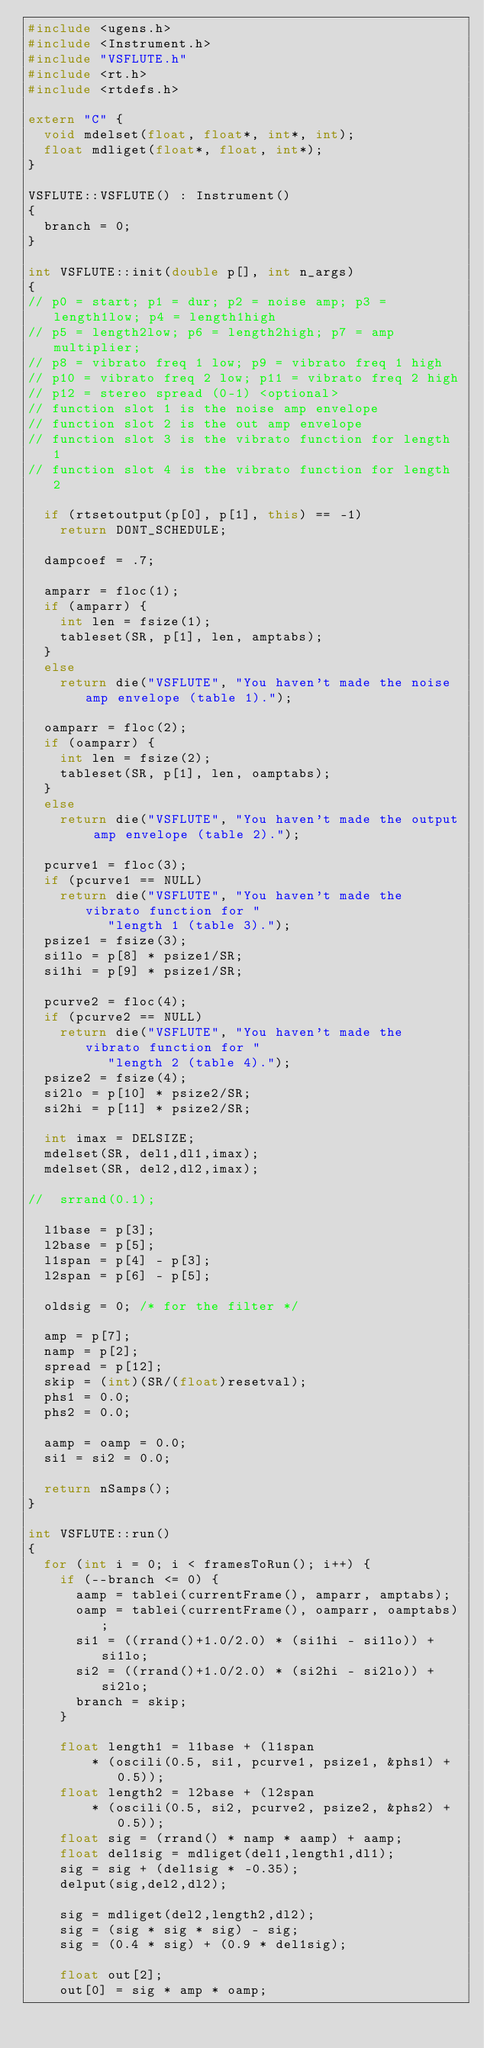Convert code to text. <code><loc_0><loc_0><loc_500><loc_500><_C++_>#include <ugens.h>
#include <Instrument.h>
#include "VSFLUTE.h"
#include <rt.h>
#include <rtdefs.h>

extern "C" {
	void mdelset(float, float*, int*, int);
	float mdliget(float*, float, int*);
}

VSFLUTE::VSFLUTE() : Instrument()
{
	branch = 0;
}

int VSFLUTE::init(double p[], int n_args)
{
// p0 = start; p1 = dur; p2 = noise amp; p3 = length1low; p4 = length1high
// p5 = length2low; p6 = length2high; p7 = amp multiplier; 
// p8 = vibrato freq 1 low; p9 = vibrato freq 1 high
// p10 = vibrato freq 2 low; p11 = vibrato freq 2 high
// p12 = stereo spread (0-1) <optional>
// function slot 1 is the noise amp envelope
// function slot 2 is the out amp envelope
// function slot 3 is the vibrato function for length 1
// function slot 4 is the vibrato function for length 2

	if (rtsetoutput(p[0], p[1], this) == -1)
		return DONT_SCHEDULE;

	dampcoef = .7;

	amparr = floc(1);
	if (amparr) {
		int len = fsize(1);
		tableset(SR, p[1], len, amptabs);
	}
	else
		return die("VSFLUTE", "You haven't made the noise amp envelope (table 1).");

	oamparr = floc(2);
	if (oamparr) {
		int len = fsize(2);
		tableset(SR, p[1], len, oamptabs);
	}
	else
		return die("VSFLUTE", "You haven't made the output amp envelope (table 2).");

	pcurve1 = floc(3);
	if (pcurve1 == NULL)
		return die("VSFLUTE", "You haven't made the vibrato function for "
					"length 1 (table 3).");
	psize1 = fsize(3);
	si1lo = p[8] * psize1/SR;
	si1hi = p[9] * psize1/SR;

	pcurve2 = floc(4);
	if (pcurve2 == NULL)
		return die("VSFLUTE", "You haven't made the vibrato function for "
					"length 2 (table 4).");
	psize2 = fsize(4);
	si2lo = p[10] * psize2/SR;
	si2hi = p[11] * psize2/SR;

	int imax = DELSIZE;
	mdelset(SR, del1,dl1,imax);
	mdelset(SR, del2,dl2,imax);

//	srrand(0.1);

	l1base = p[3];
	l2base = p[5];
	l1span = p[4] - p[3];
	l2span = p[6] - p[5];

	oldsig = 0; /* for the filter */

	amp = p[7];
	namp = p[2];
	spread = p[12];
	skip = (int)(SR/(float)resetval);
	phs1 = 0.0;
	phs2 = 0.0;

	aamp = oamp = 0.0;
	si1 = si2 = 0.0;

	return nSamps();
}

int VSFLUTE::run()
{
	for (int i = 0; i < framesToRun(); i++) {
		if (--branch <= 0) {
			aamp = tablei(currentFrame(), amparr, amptabs);
			oamp = tablei(currentFrame(), oamparr, oamptabs);
			si1 = ((rrand()+1.0/2.0) * (si1hi - si1lo)) + si1lo;
			si2 = ((rrand()+1.0/2.0) * (si2hi - si2lo)) + si2lo;
			branch = skip;
		}

		float length1 = l1base + (l1span
				* (oscili(0.5, si1, pcurve1, psize1, &phs1) + 0.5));
		float length2 = l2base + (l2span
				* (oscili(0.5, si2, pcurve2, psize2, &phs2) + 0.5));
		float sig = (rrand() * namp * aamp) + aamp;
		float del1sig = mdliget(del1,length1,dl1);
		sig = sig + (del1sig * -0.35);
		delput(sig,del2,dl2);

		sig = mdliget(del2,length2,dl2);
		sig = (sig * sig * sig) - sig;
		sig = (0.4 * sig) + (0.9 * del1sig);

		float out[2];
		out[0] = sig * amp * oamp;</code> 